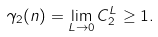Convert formula to latex. <formula><loc_0><loc_0><loc_500><loc_500>\gamma _ { 2 } ( n ) = \lim _ { L \to 0 } C _ { 2 } ^ { L } \geq 1 .</formula> 